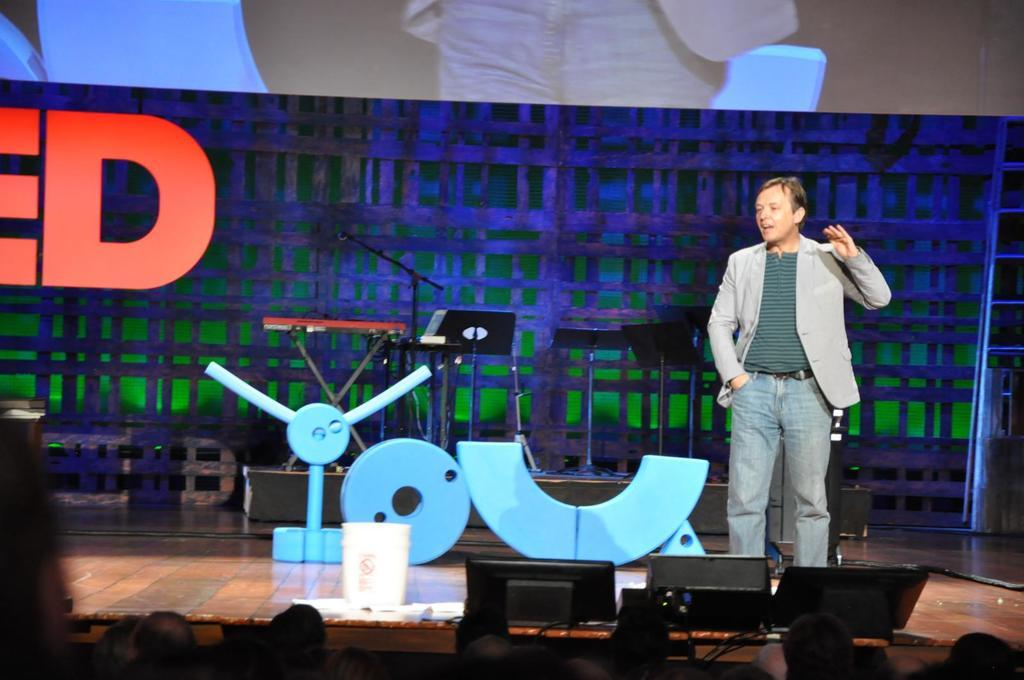What is the man in the image doing? The man is standing and speaking in the image. What is the purpose of the projector screen in the image? The projector screen is likely used for displaying visuals during the man's speech or performance. What can be seen on the raised platform in the image? There are musical instruments on a Dais in the image. Who is present in the audience in the image? There are audience members seated in the image. What type of skin is visible on the farmer's hands in the image? There is no farmer or visible skin in the image; it features a man speaking, a projector screen, musical instruments, and audience members. 